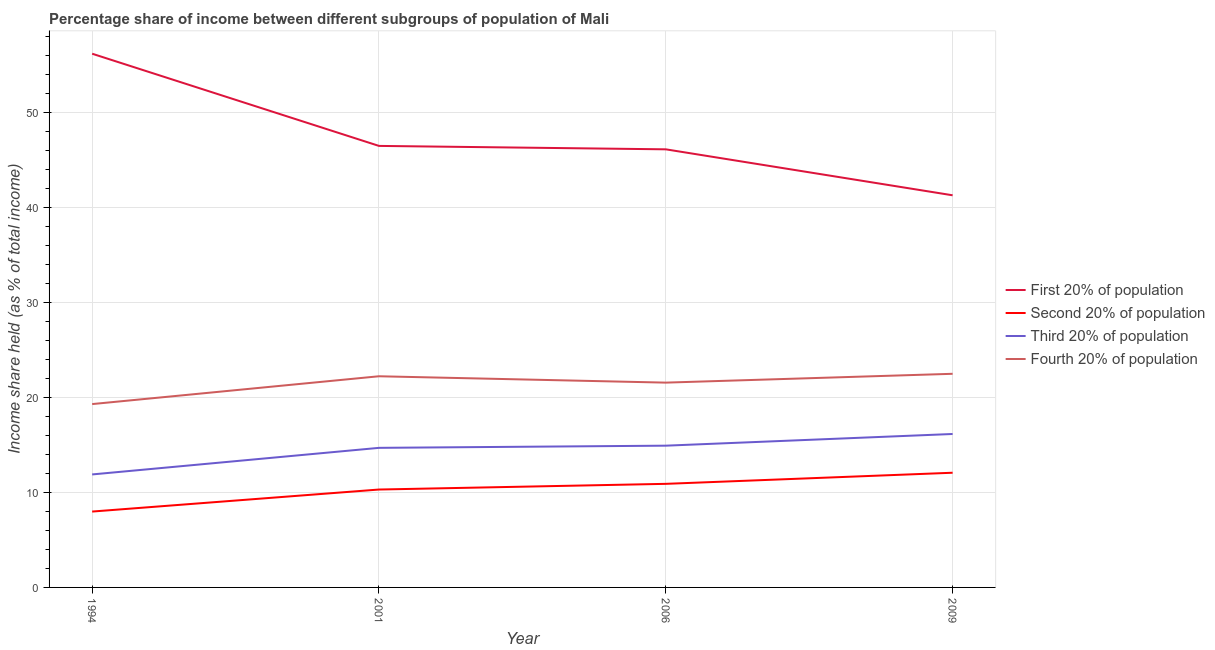How many different coloured lines are there?
Offer a terse response. 4. Does the line corresponding to share of the income held by first 20% of the population intersect with the line corresponding to share of the income held by third 20% of the population?
Make the answer very short. No. Is the number of lines equal to the number of legend labels?
Make the answer very short. Yes. What is the share of the income held by second 20% of the population in 1994?
Offer a very short reply. 7.99. Across all years, what is the maximum share of the income held by second 20% of the population?
Provide a short and direct response. 12.08. Across all years, what is the minimum share of the income held by third 20% of the population?
Provide a short and direct response. 11.9. In which year was the share of the income held by fourth 20% of the population maximum?
Offer a terse response. 2009. In which year was the share of the income held by fourth 20% of the population minimum?
Provide a short and direct response. 1994. What is the total share of the income held by fourth 20% of the population in the graph?
Your answer should be compact. 85.62. What is the difference between the share of the income held by fourth 20% of the population in 1994 and that in 2006?
Your answer should be compact. -2.26. What is the difference between the share of the income held by fourth 20% of the population in 2001 and the share of the income held by third 20% of the population in 2009?
Make the answer very short. 6.08. What is the average share of the income held by second 20% of the population per year?
Your answer should be compact. 10.32. In the year 2009, what is the difference between the share of the income held by first 20% of the population and share of the income held by fourth 20% of the population?
Keep it short and to the point. 18.8. In how many years, is the share of the income held by first 20% of the population greater than 22 %?
Offer a terse response. 4. What is the ratio of the share of the income held by fourth 20% of the population in 2001 to that in 2009?
Ensure brevity in your answer.  0.99. What is the difference between the highest and the second highest share of the income held by second 20% of the population?
Offer a very short reply. 1.17. What is the difference between the highest and the lowest share of the income held by fourth 20% of the population?
Your answer should be very brief. 3.19. Is it the case that in every year, the sum of the share of the income held by fourth 20% of the population and share of the income held by third 20% of the population is greater than the sum of share of the income held by second 20% of the population and share of the income held by first 20% of the population?
Ensure brevity in your answer.  Yes. Does the share of the income held by first 20% of the population monotonically increase over the years?
Offer a very short reply. No. Is the share of the income held by second 20% of the population strictly less than the share of the income held by fourth 20% of the population over the years?
Give a very brief answer. Yes. How many years are there in the graph?
Your answer should be very brief. 4. Are the values on the major ticks of Y-axis written in scientific E-notation?
Offer a very short reply. No. Does the graph contain any zero values?
Provide a succinct answer. No. What is the title of the graph?
Give a very brief answer. Percentage share of income between different subgroups of population of Mali. What is the label or title of the Y-axis?
Make the answer very short. Income share held (as % of total income). What is the Income share held (as % of total income) in First 20% of population in 1994?
Give a very brief answer. 56.21. What is the Income share held (as % of total income) in Second 20% of population in 1994?
Keep it short and to the point. 7.99. What is the Income share held (as % of total income) of Fourth 20% of population in 1994?
Offer a very short reply. 19.31. What is the Income share held (as % of total income) in First 20% of population in 2001?
Make the answer very short. 46.5. What is the Income share held (as % of total income) in Second 20% of population in 2001?
Keep it short and to the point. 10.31. What is the Income share held (as % of total income) of Fourth 20% of population in 2001?
Give a very brief answer. 22.24. What is the Income share held (as % of total income) of First 20% of population in 2006?
Provide a short and direct response. 46.14. What is the Income share held (as % of total income) of Second 20% of population in 2006?
Ensure brevity in your answer.  10.91. What is the Income share held (as % of total income) of Third 20% of population in 2006?
Keep it short and to the point. 14.93. What is the Income share held (as % of total income) of Fourth 20% of population in 2006?
Give a very brief answer. 21.57. What is the Income share held (as % of total income) in First 20% of population in 2009?
Your answer should be very brief. 41.3. What is the Income share held (as % of total income) in Second 20% of population in 2009?
Your answer should be compact. 12.08. What is the Income share held (as % of total income) in Third 20% of population in 2009?
Provide a short and direct response. 16.16. Across all years, what is the maximum Income share held (as % of total income) in First 20% of population?
Provide a short and direct response. 56.21. Across all years, what is the maximum Income share held (as % of total income) of Second 20% of population?
Your response must be concise. 12.08. Across all years, what is the maximum Income share held (as % of total income) of Third 20% of population?
Ensure brevity in your answer.  16.16. Across all years, what is the maximum Income share held (as % of total income) of Fourth 20% of population?
Offer a very short reply. 22.5. Across all years, what is the minimum Income share held (as % of total income) in First 20% of population?
Provide a short and direct response. 41.3. Across all years, what is the minimum Income share held (as % of total income) of Second 20% of population?
Your answer should be compact. 7.99. Across all years, what is the minimum Income share held (as % of total income) in Fourth 20% of population?
Offer a terse response. 19.31. What is the total Income share held (as % of total income) in First 20% of population in the graph?
Keep it short and to the point. 190.15. What is the total Income share held (as % of total income) of Second 20% of population in the graph?
Give a very brief answer. 41.29. What is the total Income share held (as % of total income) in Third 20% of population in the graph?
Ensure brevity in your answer.  57.69. What is the total Income share held (as % of total income) of Fourth 20% of population in the graph?
Provide a succinct answer. 85.62. What is the difference between the Income share held (as % of total income) of First 20% of population in 1994 and that in 2001?
Ensure brevity in your answer.  9.71. What is the difference between the Income share held (as % of total income) of Second 20% of population in 1994 and that in 2001?
Your answer should be compact. -2.32. What is the difference between the Income share held (as % of total income) in Fourth 20% of population in 1994 and that in 2001?
Your response must be concise. -2.93. What is the difference between the Income share held (as % of total income) of First 20% of population in 1994 and that in 2006?
Your answer should be very brief. 10.07. What is the difference between the Income share held (as % of total income) in Second 20% of population in 1994 and that in 2006?
Keep it short and to the point. -2.92. What is the difference between the Income share held (as % of total income) of Third 20% of population in 1994 and that in 2006?
Make the answer very short. -3.03. What is the difference between the Income share held (as % of total income) in Fourth 20% of population in 1994 and that in 2006?
Make the answer very short. -2.26. What is the difference between the Income share held (as % of total income) of First 20% of population in 1994 and that in 2009?
Offer a terse response. 14.91. What is the difference between the Income share held (as % of total income) in Second 20% of population in 1994 and that in 2009?
Your answer should be very brief. -4.09. What is the difference between the Income share held (as % of total income) in Third 20% of population in 1994 and that in 2009?
Keep it short and to the point. -4.26. What is the difference between the Income share held (as % of total income) of Fourth 20% of population in 1994 and that in 2009?
Your response must be concise. -3.19. What is the difference between the Income share held (as % of total income) in First 20% of population in 2001 and that in 2006?
Make the answer very short. 0.36. What is the difference between the Income share held (as % of total income) in Third 20% of population in 2001 and that in 2006?
Your answer should be compact. -0.23. What is the difference between the Income share held (as % of total income) in Fourth 20% of population in 2001 and that in 2006?
Provide a short and direct response. 0.67. What is the difference between the Income share held (as % of total income) in First 20% of population in 2001 and that in 2009?
Make the answer very short. 5.2. What is the difference between the Income share held (as % of total income) of Second 20% of population in 2001 and that in 2009?
Make the answer very short. -1.77. What is the difference between the Income share held (as % of total income) of Third 20% of population in 2001 and that in 2009?
Keep it short and to the point. -1.46. What is the difference between the Income share held (as % of total income) in Fourth 20% of population in 2001 and that in 2009?
Make the answer very short. -0.26. What is the difference between the Income share held (as % of total income) of First 20% of population in 2006 and that in 2009?
Offer a very short reply. 4.84. What is the difference between the Income share held (as % of total income) in Second 20% of population in 2006 and that in 2009?
Provide a succinct answer. -1.17. What is the difference between the Income share held (as % of total income) of Third 20% of population in 2006 and that in 2009?
Ensure brevity in your answer.  -1.23. What is the difference between the Income share held (as % of total income) in Fourth 20% of population in 2006 and that in 2009?
Provide a short and direct response. -0.93. What is the difference between the Income share held (as % of total income) of First 20% of population in 1994 and the Income share held (as % of total income) of Second 20% of population in 2001?
Provide a short and direct response. 45.9. What is the difference between the Income share held (as % of total income) in First 20% of population in 1994 and the Income share held (as % of total income) in Third 20% of population in 2001?
Offer a very short reply. 41.51. What is the difference between the Income share held (as % of total income) of First 20% of population in 1994 and the Income share held (as % of total income) of Fourth 20% of population in 2001?
Your response must be concise. 33.97. What is the difference between the Income share held (as % of total income) in Second 20% of population in 1994 and the Income share held (as % of total income) in Third 20% of population in 2001?
Make the answer very short. -6.71. What is the difference between the Income share held (as % of total income) of Second 20% of population in 1994 and the Income share held (as % of total income) of Fourth 20% of population in 2001?
Provide a short and direct response. -14.25. What is the difference between the Income share held (as % of total income) of Third 20% of population in 1994 and the Income share held (as % of total income) of Fourth 20% of population in 2001?
Ensure brevity in your answer.  -10.34. What is the difference between the Income share held (as % of total income) in First 20% of population in 1994 and the Income share held (as % of total income) in Second 20% of population in 2006?
Provide a short and direct response. 45.3. What is the difference between the Income share held (as % of total income) of First 20% of population in 1994 and the Income share held (as % of total income) of Third 20% of population in 2006?
Your answer should be very brief. 41.28. What is the difference between the Income share held (as % of total income) in First 20% of population in 1994 and the Income share held (as % of total income) in Fourth 20% of population in 2006?
Your response must be concise. 34.64. What is the difference between the Income share held (as % of total income) of Second 20% of population in 1994 and the Income share held (as % of total income) of Third 20% of population in 2006?
Provide a short and direct response. -6.94. What is the difference between the Income share held (as % of total income) of Second 20% of population in 1994 and the Income share held (as % of total income) of Fourth 20% of population in 2006?
Make the answer very short. -13.58. What is the difference between the Income share held (as % of total income) in Third 20% of population in 1994 and the Income share held (as % of total income) in Fourth 20% of population in 2006?
Provide a succinct answer. -9.67. What is the difference between the Income share held (as % of total income) in First 20% of population in 1994 and the Income share held (as % of total income) in Second 20% of population in 2009?
Keep it short and to the point. 44.13. What is the difference between the Income share held (as % of total income) of First 20% of population in 1994 and the Income share held (as % of total income) of Third 20% of population in 2009?
Ensure brevity in your answer.  40.05. What is the difference between the Income share held (as % of total income) of First 20% of population in 1994 and the Income share held (as % of total income) of Fourth 20% of population in 2009?
Your response must be concise. 33.71. What is the difference between the Income share held (as % of total income) of Second 20% of population in 1994 and the Income share held (as % of total income) of Third 20% of population in 2009?
Keep it short and to the point. -8.17. What is the difference between the Income share held (as % of total income) of Second 20% of population in 1994 and the Income share held (as % of total income) of Fourth 20% of population in 2009?
Offer a very short reply. -14.51. What is the difference between the Income share held (as % of total income) of Third 20% of population in 1994 and the Income share held (as % of total income) of Fourth 20% of population in 2009?
Provide a succinct answer. -10.6. What is the difference between the Income share held (as % of total income) of First 20% of population in 2001 and the Income share held (as % of total income) of Second 20% of population in 2006?
Your answer should be compact. 35.59. What is the difference between the Income share held (as % of total income) of First 20% of population in 2001 and the Income share held (as % of total income) of Third 20% of population in 2006?
Provide a short and direct response. 31.57. What is the difference between the Income share held (as % of total income) in First 20% of population in 2001 and the Income share held (as % of total income) in Fourth 20% of population in 2006?
Give a very brief answer. 24.93. What is the difference between the Income share held (as % of total income) of Second 20% of population in 2001 and the Income share held (as % of total income) of Third 20% of population in 2006?
Provide a succinct answer. -4.62. What is the difference between the Income share held (as % of total income) in Second 20% of population in 2001 and the Income share held (as % of total income) in Fourth 20% of population in 2006?
Ensure brevity in your answer.  -11.26. What is the difference between the Income share held (as % of total income) of Third 20% of population in 2001 and the Income share held (as % of total income) of Fourth 20% of population in 2006?
Provide a short and direct response. -6.87. What is the difference between the Income share held (as % of total income) of First 20% of population in 2001 and the Income share held (as % of total income) of Second 20% of population in 2009?
Offer a very short reply. 34.42. What is the difference between the Income share held (as % of total income) of First 20% of population in 2001 and the Income share held (as % of total income) of Third 20% of population in 2009?
Your response must be concise. 30.34. What is the difference between the Income share held (as % of total income) in First 20% of population in 2001 and the Income share held (as % of total income) in Fourth 20% of population in 2009?
Your answer should be compact. 24. What is the difference between the Income share held (as % of total income) of Second 20% of population in 2001 and the Income share held (as % of total income) of Third 20% of population in 2009?
Keep it short and to the point. -5.85. What is the difference between the Income share held (as % of total income) in Second 20% of population in 2001 and the Income share held (as % of total income) in Fourth 20% of population in 2009?
Make the answer very short. -12.19. What is the difference between the Income share held (as % of total income) in Third 20% of population in 2001 and the Income share held (as % of total income) in Fourth 20% of population in 2009?
Make the answer very short. -7.8. What is the difference between the Income share held (as % of total income) in First 20% of population in 2006 and the Income share held (as % of total income) in Second 20% of population in 2009?
Your answer should be compact. 34.06. What is the difference between the Income share held (as % of total income) in First 20% of population in 2006 and the Income share held (as % of total income) in Third 20% of population in 2009?
Offer a very short reply. 29.98. What is the difference between the Income share held (as % of total income) of First 20% of population in 2006 and the Income share held (as % of total income) of Fourth 20% of population in 2009?
Give a very brief answer. 23.64. What is the difference between the Income share held (as % of total income) of Second 20% of population in 2006 and the Income share held (as % of total income) of Third 20% of population in 2009?
Provide a succinct answer. -5.25. What is the difference between the Income share held (as % of total income) of Second 20% of population in 2006 and the Income share held (as % of total income) of Fourth 20% of population in 2009?
Keep it short and to the point. -11.59. What is the difference between the Income share held (as % of total income) of Third 20% of population in 2006 and the Income share held (as % of total income) of Fourth 20% of population in 2009?
Keep it short and to the point. -7.57. What is the average Income share held (as % of total income) of First 20% of population per year?
Your answer should be very brief. 47.54. What is the average Income share held (as % of total income) of Second 20% of population per year?
Your response must be concise. 10.32. What is the average Income share held (as % of total income) of Third 20% of population per year?
Give a very brief answer. 14.42. What is the average Income share held (as % of total income) in Fourth 20% of population per year?
Your answer should be compact. 21.41. In the year 1994, what is the difference between the Income share held (as % of total income) of First 20% of population and Income share held (as % of total income) of Second 20% of population?
Keep it short and to the point. 48.22. In the year 1994, what is the difference between the Income share held (as % of total income) of First 20% of population and Income share held (as % of total income) of Third 20% of population?
Give a very brief answer. 44.31. In the year 1994, what is the difference between the Income share held (as % of total income) in First 20% of population and Income share held (as % of total income) in Fourth 20% of population?
Keep it short and to the point. 36.9. In the year 1994, what is the difference between the Income share held (as % of total income) in Second 20% of population and Income share held (as % of total income) in Third 20% of population?
Provide a succinct answer. -3.91. In the year 1994, what is the difference between the Income share held (as % of total income) of Second 20% of population and Income share held (as % of total income) of Fourth 20% of population?
Provide a succinct answer. -11.32. In the year 1994, what is the difference between the Income share held (as % of total income) of Third 20% of population and Income share held (as % of total income) of Fourth 20% of population?
Your answer should be very brief. -7.41. In the year 2001, what is the difference between the Income share held (as % of total income) in First 20% of population and Income share held (as % of total income) in Second 20% of population?
Keep it short and to the point. 36.19. In the year 2001, what is the difference between the Income share held (as % of total income) in First 20% of population and Income share held (as % of total income) in Third 20% of population?
Your answer should be very brief. 31.8. In the year 2001, what is the difference between the Income share held (as % of total income) in First 20% of population and Income share held (as % of total income) in Fourth 20% of population?
Your response must be concise. 24.26. In the year 2001, what is the difference between the Income share held (as % of total income) of Second 20% of population and Income share held (as % of total income) of Third 20% of population?
Offer a very short reply. -4.39. In the year 2001, what is the difference between the Income share held (as % of total income) in Second 20% of population and Income share held (as % of total income) in Fourth 20% of population?
Your answer should be compact. -11.93. In the year 2001, what is the difference between the Income share held (as % of total income) in Third 20% of population and Income share held (as % of total income) in Fourth 20% of population?
Provide a succinct answer. -7.54. In the year 2006, what is the difference between the Income share held (as % of total income) of First 20% of population and Income share held (as % of total income) of Second 20% of population?
Provide a short and direct response. 35.23. In the year 2006, what is the difference between the Income share held (as % of total income) in First 20% of population and Income share held (as % of total income) in Third 20% of population?
Your response must be concise. 31.21. In the year 2006, what is the difference between the Income share held (as % of total income) of First 20% of population and Income share held (as % of total income) of Fourth 20% of population?
Provide a succinct answer. 24.57. In the year 2006, what is the difference between the Income share held (as % of total income) of Second 20% of population and Income share held (as % of total income) of Third 20% of population?
Make the answer very short. -4.02. In the year 2006, what is the difference between the Income share held (as % of total income) in Second 20% of population and Income share held (as % of total income) in Fourth 20% of population?
Provide a succinct answer. -10.66. In the year 2006, what is the difference between the Income share held (as % of total income) of Third 20% of population and Income share held (as % of total income) of Fourth 20% of population?
Keep it short and to the point. -6.64. In the year 2009, what is the difference between the Income share held (as % of total income) of First 20% of population and Income share held (as % of total income) of Second 20% of population?
Give a very brief answer. 29.22. In the year 2009, what is the difference between the Income share held (as % of total income) of First 20% of population and Income share held (as % of total income) of Third 20% of population?
Provide a short and direct response. 25.14. In the year 2009, what is the difference between the Income share held (as % of total income) of Second 20% of population and Income share held (as % of total income) of Third 20% of population?
Offer a very short reply. -4.08. In the year 2009, what is the difference between the Income share held (as % of total income) of Second 20% of population and Income share held (as % of total income) of Fourth 20% of population?
Keep it short and to the point. -10.42. In the year 2009, what is the difference between the Income share held (as % of total income) in Third 20% of population and Income share held (as % of total income) in Fourth 20% of population?
Ensure brevity in your answer.  -6.34. What is the ratio of the Income share held (as % of total income) in First 20% of population in 1994 to that in 2001?
Keep it short and to the point. 1.21. What is the ratio of the Income share held (as % of total income) in Second 20% of population in 1994 to that in 2001?
Your answer should be compact. 0.78. What is the ratio of the Income share held (as % of total income) in Third 20% of population in 1994 to that in 2001?
Offer a very short reply. 0.81. What is the ratio of the Income share held (as % of total income) of Fourth 20% of population in 1994 to that in 2001?
Give a very brief answer. 0.87. What is the ratio of the Income share held (as % of total income) of First 20% of population in 1994 to that in 2006?
Your answer should be very brief. 1.22. What is the ratio of the Income share held (as % of total income) of Second 20% of population in 1994 to that in 2006?
Give a very brief answer. 0.73. What is the ratio of the Income share held (as % of total income) of Third 20% of population in 1994 to that in 2006?
Provide a succinct answer. 0.8. What is the ratio of the Income share held (as % of total income) of Fourth 20% of population in 1994 to that in 2006?
Offer a very short reply. 0.9. What is the ratio of the Income share held (as % of total income) of First 20% of population in 1994 to that in 2009?
Provide a succinct answer. 1.36. What is the ratio of the Income share held (as % of total income) of Second 20% of population in 1994 to that in 2009?
Your response must be concise. 0.66. What is the ratio of the Income share held (as % of total income) in Third 20% of population in 1994 to that in 2009?
Your answer should be compact. 0.74. What is the ratio of the Income share held (as % of total income) in Fourth 20% of population in 1994 to that in 2009?
Provide a succinct answer. 0.86. What is the ratio of the Income share held (as % of total income) in First 20% of population in 2001 to that in 2006?
Your response must be concise. 1.01. What is the ratio of the Income share held (as % of total income) in Second 20% of population in 2001 to that in 2006?
Provide a short and direct response. 0.94. What is the ratio of the Income share held (as % of total income) of Third 20% of population in 2001 to that in 2006?
Provide a succinct answer. 0.98. What is the ratio of the Income share held (as % of total income) in Fourth 20% of population in 2001 to that in 2006?
Ensure brevity in your answer.  1.03. What is the ratio of the Income share held (as % of total income) in First 20% of population in 2001 to that in 2009?
Offer a very short reply. 1.13. What is the ratio of the Income share held (as % of total income) of Second 20% of population in 2001 to that in 2009?
Keep it short and to the point. 0.85. What is the ratio of the Income share held (as % of total income) of Third 20% of population in 2001 to that in 2009?
Provide a succinct answer. 0.91. What is the ratio of the Income share held (as % of total income) of Fourth 20% of population in 2001 to that in 2009?
Ensure brevity in your answer.  0.99. What is the ratio of the Income share held (as % of total income) of First 20% of population in 2006 to that in 2009?
Ensure brevity in your answer.  1.12. What is the ratio of the Income share held (as % of total income) of Second 20% of population in 2006 to that in 2009?
Give a very brief answer. 0.9. What is the ratio of the Income share held (as % of total income) of Third 20% of population in 2006 to that in 2009?
Offer a terse response. 0.92. What is the ratio of the Income share held (as % of total income) in Fourth 20% of population in 2006 to that in 2009?
Make the answer very short. 0.96. What is the difference between the highest and the second highest Income share held (as % of total income) in First 20% of population?
Offer a terse response. 9.71. What is the difference between the highest and the second highest Income share held (as % of total income) of Second 20% of population?
Your answer should be very brief. 1.17. What is the difference between the highest and the second highest Income share held (as % of total income) of Third 20% of population?
Your answer should be compact. 1.23. What is the difference between the highest and the second highest Income share held (as % of total income) in Fourth 20% of population?
Your answer should be compact. 0.26. What is the difference between the highest and the lowest Income share held (as % of total income) of First 20% of population?
Your answer should be compact. 14.91. What is the difference between the highest and the lowest Income share held (as % of total income) of Second 20% of population?
Your answer should be very brief. 4.09. What is the difference between the highest and the lowest Income share held (as % of total income) in Third 20% of population?
Offer a terse response. 4.26. What is the difference between the highest and the lowest Income share held (as % of total income) of Fourth 20% of population?
Your answer should be very brief. 3.19. 